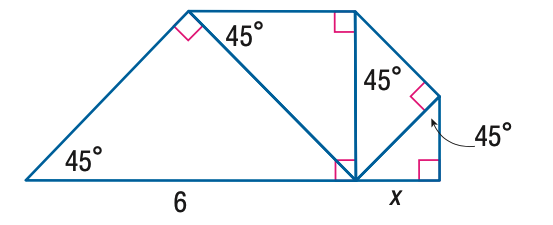Question: Each triangle in the figure is a 45 - 45 - 90 triangle. Find x.
Choices:
A. \frac { 3 } { 2 }
B. \frac { 3 } { 2 } \sqrt { 2 }
C. 3
D. 3 \sqrt { 2 }
Answer with the letter. Answer: A 